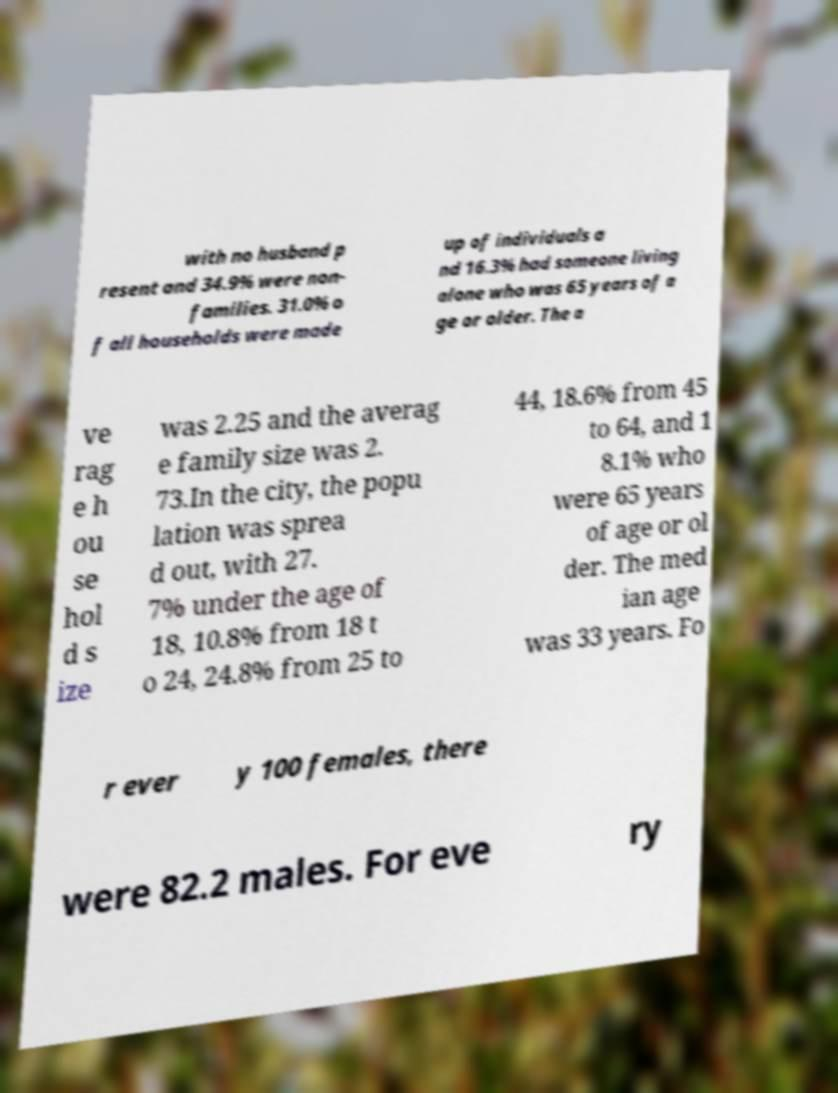Please read and relay the text visible in this image. What does it say? with no husband p resent and 34.9% were non- families. 31.0% o f all households were made up of individuals a nd 16.3% had someone living alone who was 65 years of a ge or older. The a ve rag e h ou se hol d s ize was 2.25 and the averag e family size was 2. 73.In the city, the popu lation was sprea d out, with 27. 7% under the age of 18, 10.8% from 18 t o 24, 24.8% from 25 to 44, 18.6% from 45 to 64, and 1 8.1% who were 65 years of age or ol der. The med ian age was 33 years. Fo r ever y 100 females, there were 82.2 males. For eve ry 